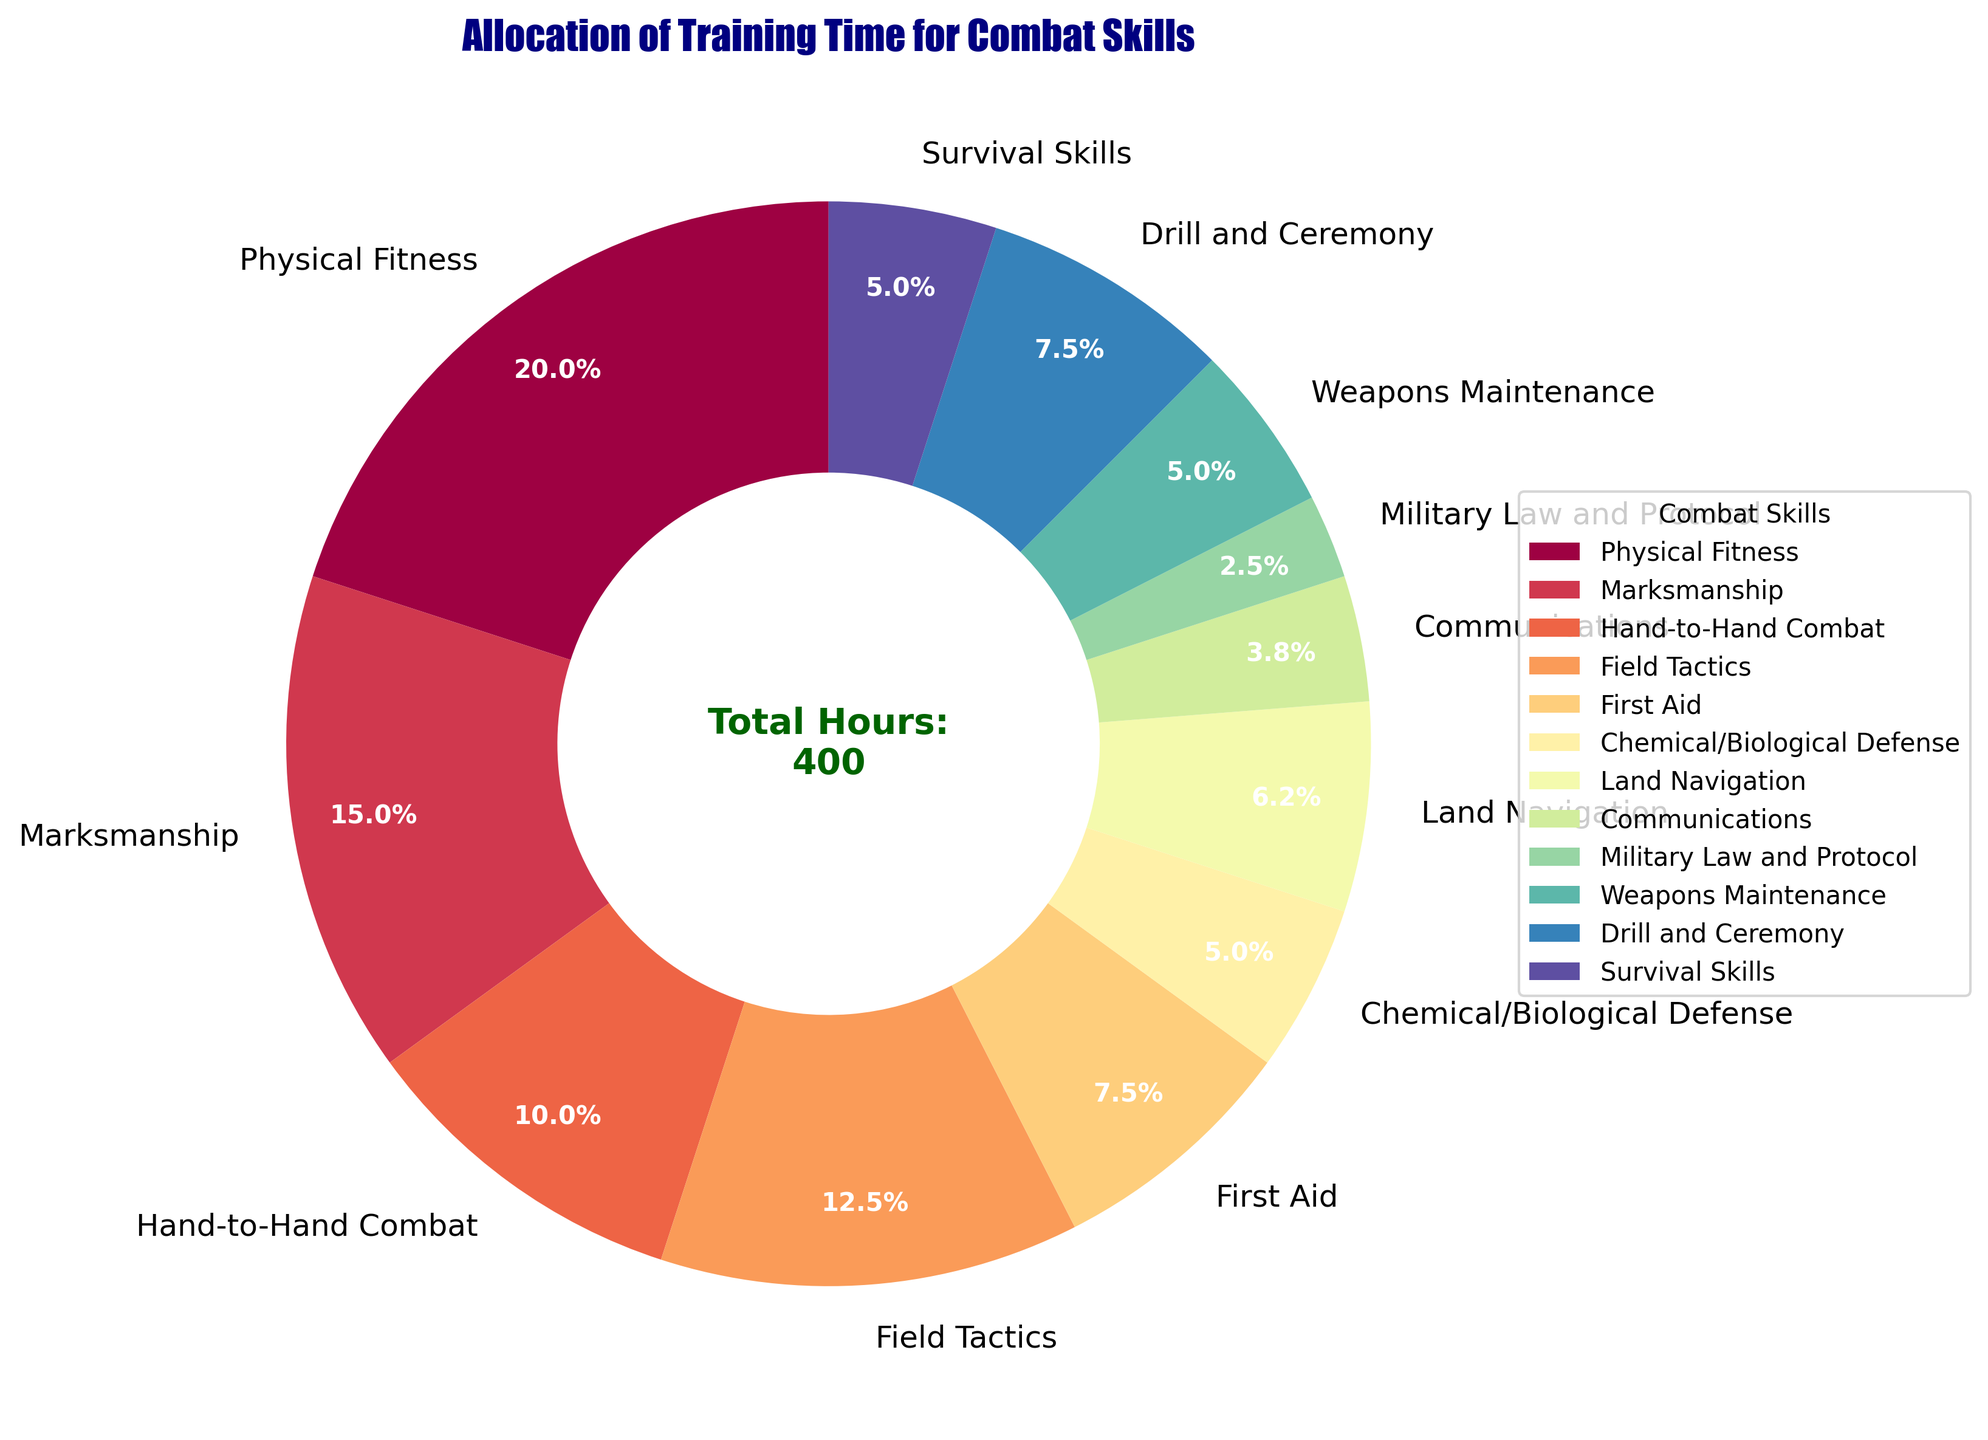What skill occupies the largest portion of the pie chart? The largest portion of the pie chart is the segment with the highest percentage value. By looking at the labels, we can see that Physical Fitness takes up 24.2% of the chart.
Answer: Physical Fitness How much more training time is allocated to Marksmanship compared to Communications? Marksmanship takes up 60 hours and Communications takes up 15 hours. Subtract the hours allocated to Communications from those allocated to Marksmanship: 60 - 15 = 45.
Answer: 45 hours Which skill has the smallest portion, and what percentage does it represent? The smallest portion is identified by the smallest percentage value in the pie chart. Military Law and Protocol is labeled with 3.0%, which is the smallest.
Answer: Military Law and Protocol, 3.0% What is the combined percentage of training time allocated to Field Tactics and Land Navigation? Field Tactics takes up 15.2% and Land Navigation takes up 7.6%. Add these values together to find the combined percentage: 15.2% + 7.6% = 22.8%.
Answer: 22.8% How does the time allocated for Weapons Maintenance compare to that for Chemical/Biological Defense? Weapons Maintenance and Chemical/Biological Defense each take up the same number of hours, 6.1%. Therefore, they are equal in allocation.
Answer: They are equal What is the total percentage of training time dedicated to the skills that have 20 hours allocated each? The skills given 20 hours are Chemical/Biological Defense, Weapons Maintenance, and Survival Skills. Each represents 6.1%. Add these percentages up: 6.1% + 6.1% + 6.1% = 18.3%.
Answer: 18.3% What differences can you observe between the time allocated to Drill and Ceremony and First Aid? Drill and Ceremony takes up 9.1% while First Aid takes up 9.1%, indicating both skills have equal time allocation.
Answer: They are equal Which skill is allocated more time, Land Navigation or Hand-to-Hand Combat, and by how much? Hand-to-Hand Combat takes up 12.1% and Land Navigation takes up 7.6%. Subtract the smaller percentage from the larger one to find the difference: 12.1% - 7.6% = 4.5%.
Answer: Hand-to-Hand Combat by 4.5% What's the combined total percentage of the three skills with the lowest time allocation? Military Law and Protocol (3.0%), Communications (4.5%), and Chemical/Biological Defense (6.1%) collectively have the lowest allocation. Add their percentages together: 3.0% + 4.5% + 6.1% = 13.6%.
Answer: 13.6% What are the primary colors used in the pie chart? The colors used in the chart are derived from the Spectral color map. The primary colors are various shades, including red, blue, green, purple, and yellow.
Answer: Red, blue, green, purple, yellow 